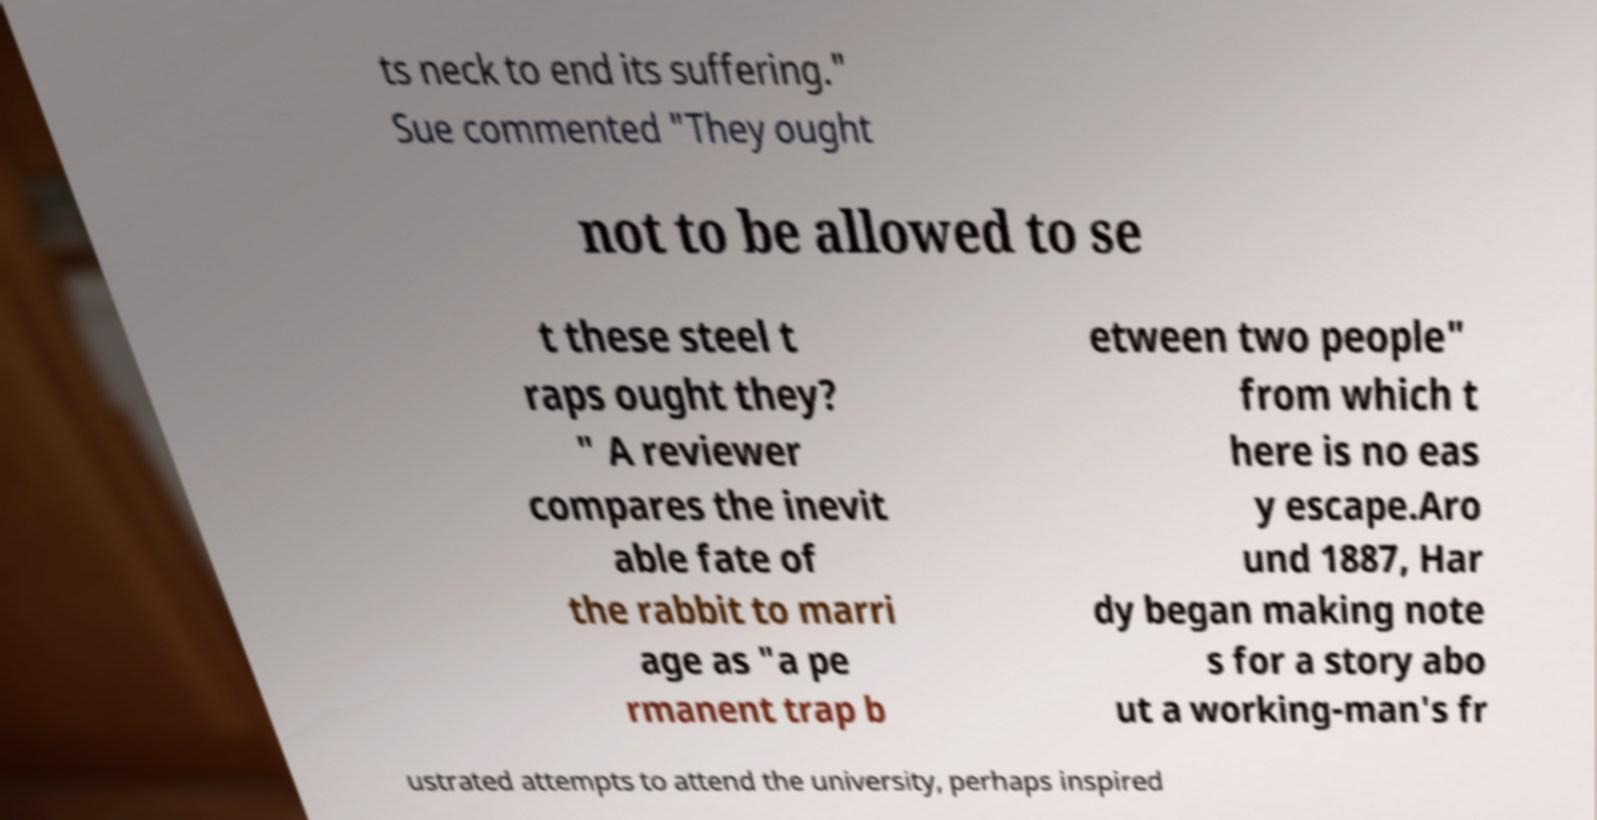Please read and relay the text visible in this image. What does it say? ts neck to end its suffering." Sue commented "They ought not to be allowed to se t these steel t raps ought they? " A reviewer compares the inevit able fate of the rabbit to marri age as "a pe rmanent trap b etween two people" from which t here is no eas y escape.Aro und 1887, Har dy began making note s for a story abo ut a working-man's fr ustrated attempts to attend the university, perhaps inspired 